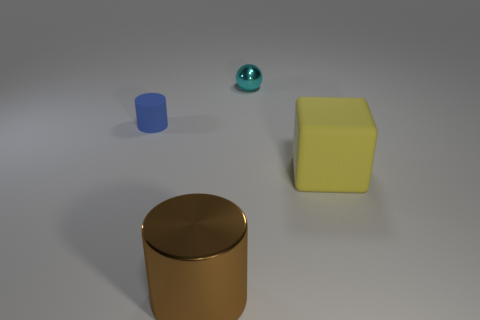Are there an equal number of large brown cylinders to the right of the small cyan metal sphere and tiny spheres?
Provide a succinct answer. No. How many things are either tiny purple rubber cylinders or big things?
Ensure brevity in your answer.  2. Is there anything else that is the same shape as the small metal thing?
Give a very brief answer. No. What is the shape of the small thing that is in front of the metal object right of the brown object?
Ensure brevity in your answer.  Cylinder. What is the shape of the tiny cyan thing that is made of the same material as the large brown cylinder?
Keep it short and to the point. Sphere. What size is the matte thing to the left of the rubber thing right of the large cylinder?
Your answer should be very brief. Small. What shape is the large rubber object?
Provide a short and direct response. Cube. How many tiny objects are yellow things or brown blocks?
Provide a short and direct response. 0. There is a matte object that is the same shape as the brown shiny object; what size is it?
Provide a succinct answer. Small. What number of things are right of the large brown cylinder and left of the big rubber cube?
Your answer should be very brief. 1. 